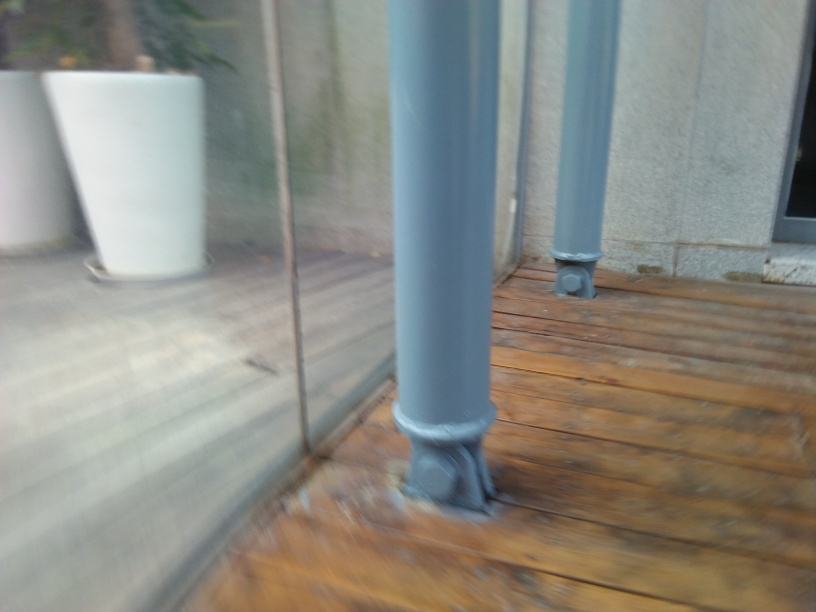What do you think is the purpose of the structures shown in the image? The structures in the image are support pillars, likely part of a larger architectural design, possibly a patio or balcony. Their purpose is to provide structural support to the overlying construction. 